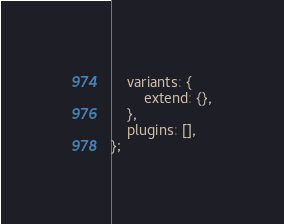<code> <loc_0><loc_0><loc_500><loc_500><_JavaScript_>    variants: {
        extend: {},
    },
    plugins: [],
};
</code> 